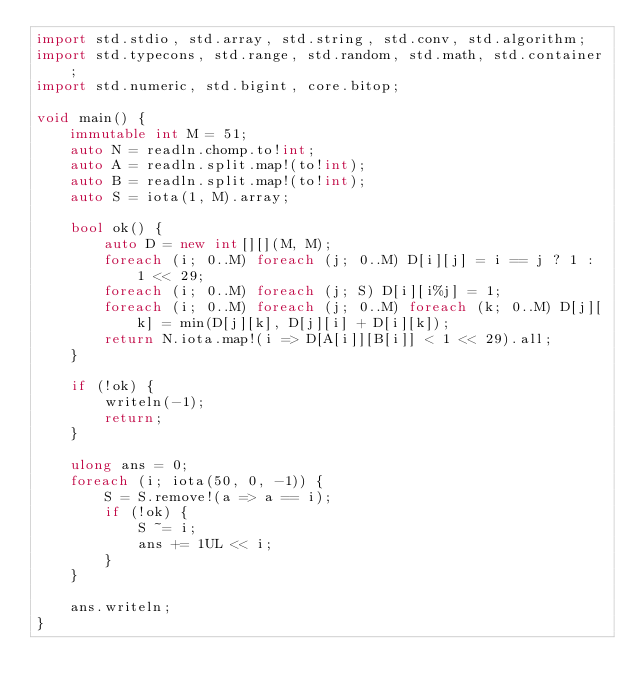<code> <loc_0><loc_0><loc_500><loc_500><_D_>import std.stdio, std.array, std.string, std.conv, std.algorithm;
import std.typecons, std.range, std.random, std.math, std.container;
import std.numeric, std.bigint, core.bitop;

void main() {
    immutable int M = 51;
    auto N = readln.chomp.to!int;
    auto A = readln.split.map!(to!int);
    auto B = readln.split.map!(to!int);
    auto S = iota(1, M).array;

    bool ok() {
        auto D = new int[][](M, M);
        foreach (i; 0..M) foreach (j; 0..M) D[i][j] = i == j ? 1 : 1 << 29;
        foreach (i; 0..M) foreach (j; S) D[i][i%j] = 1;
        foreach (i; 0..M) foreach (j; 0..M) foreach (k; 0..M) D[j][k] = min(D[j][k], D[j][i] + D[i][k]);
        return N.iota.map!(i => D[A[i]][B[i]] < 1 << 29).all;
    }

    if (!ok) {
        writeln(-1);
        return;
    }
    
    ulong ans = 0;
    foreach (i; iota(50, 0, -1)) {
        S = S.remove!(a => a == i);
        if (!ok) {
            S ~= i;
            ans += 1UL << i;
        }
    }

    ans.writeln;
}
</code> 